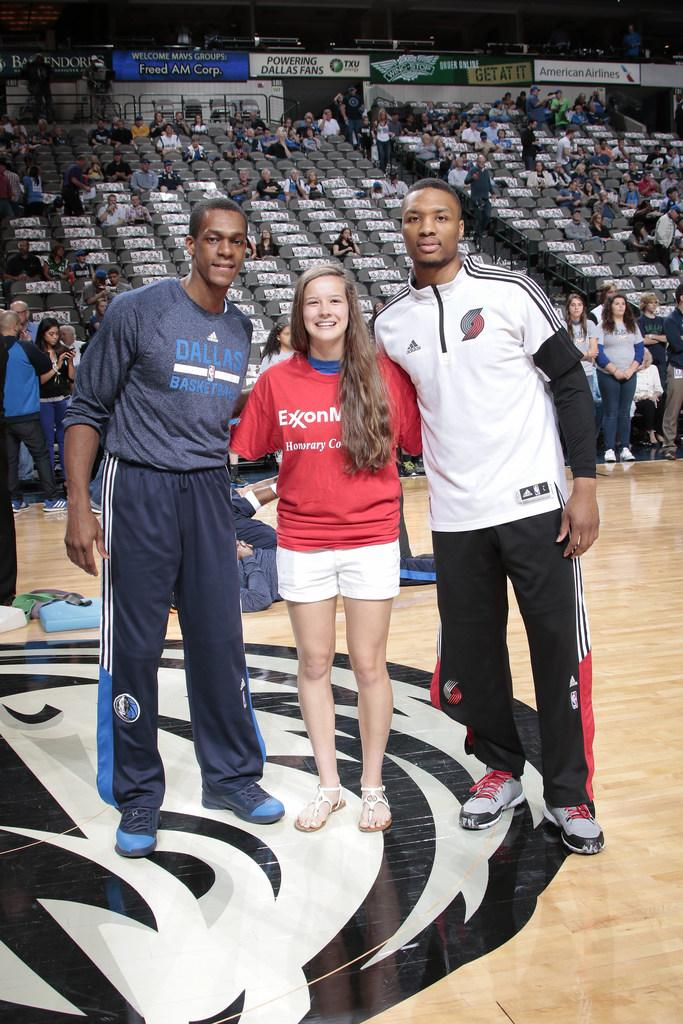<image>
Summarize the visual content of the image. A young girl wearing a red Exxon Mobile shirt is standing between two male basketball players on the court. 